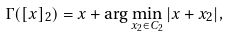Convert formula to latex. <formula><loc_0><loc_0><loc_500><loc_500>\Gamma ( [ x ] _ { 2 } ) = x + \arg \min _ { x _ { 2 } \in C _ { 2 } } | x + x _ { 2 } | ,</formula> 